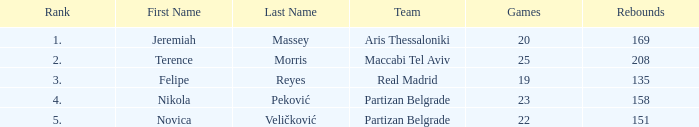How many Games for Terence Morris? 25.0. 